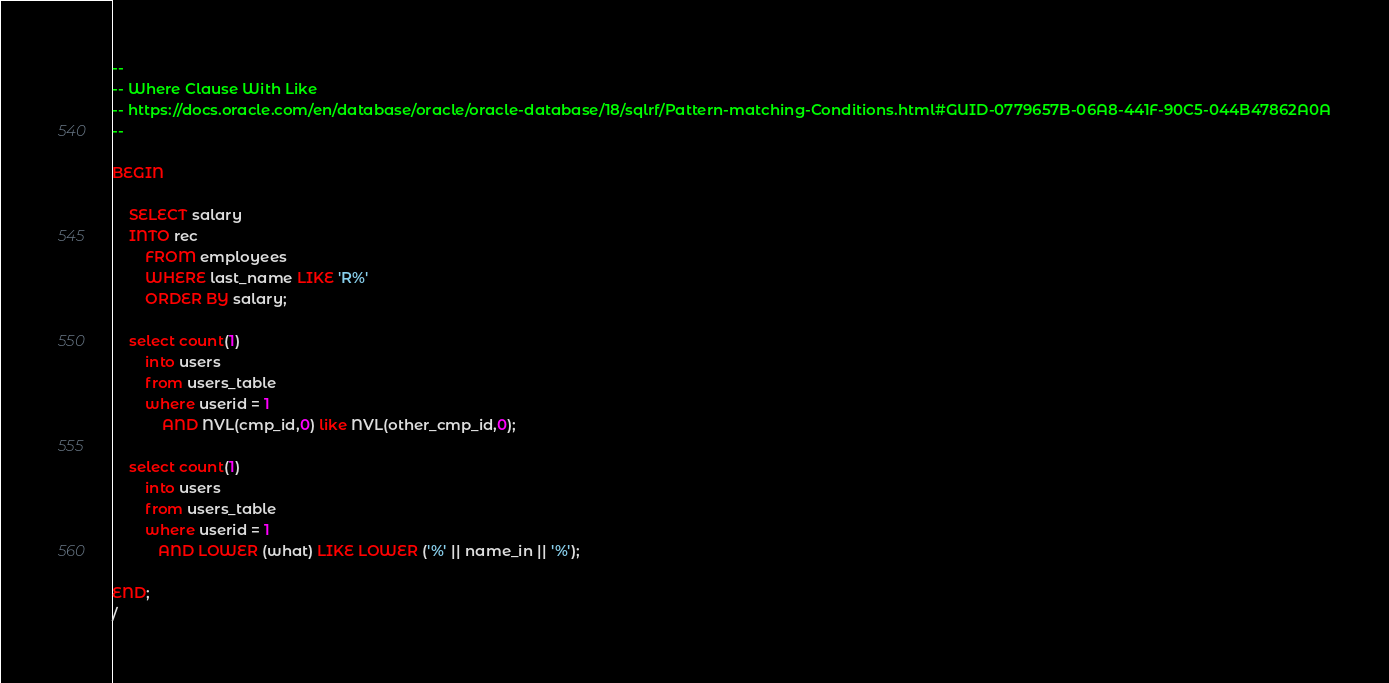<code> <loc_0><loc_0><loc_500><loc_500><_SQL_>--
-- Where Clause With Like
-- https://docs.oracle.com/en/database/oracle/oracle-database/18/sqlrf/Pattern-matching-Conditions.html#GUID-0779657B-06A8-441F-90C5-044B47862A0A
--

BEGIN

    SELECT salary 
    INTO rec
        FROM employees
        WHERE last_name LIKE 'R%'
        ORDER BY salary;

    select count(1)
        into users
        from users_table
        where userid = 1
            AND NVL(cmp_id,0) like NVL(other_cmp_id,0);

    select count(1)
        into users
        from users_table
        where userid = 1
           AND LOWER (what) LIKE LOWER ('%' || name_in || '%');

END;
/
</code> 